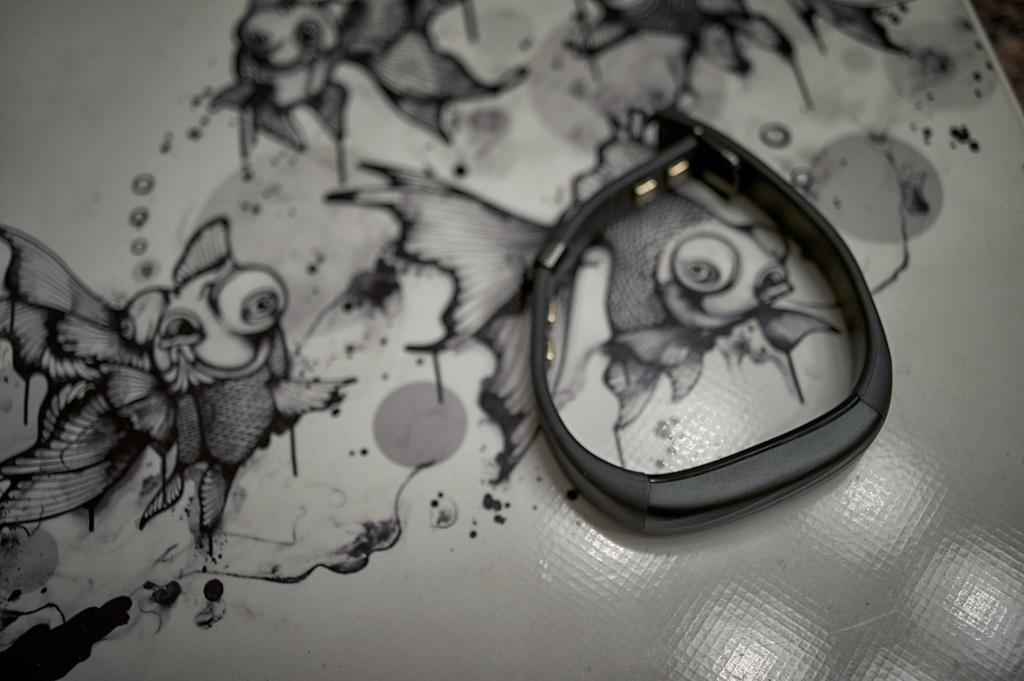What is the main object in the image? There is a Fitbit in the image. What is the Fitbit placed on? The Fitbit is placed on a white color sheet. What else can be seen on the sheet? There are paintings visible on the sheet. Can you tell me how many people are shopping in the image? There is no reference to shopping or people in the image; it only features a Fitbit placed on a white color sheet with paintings. 